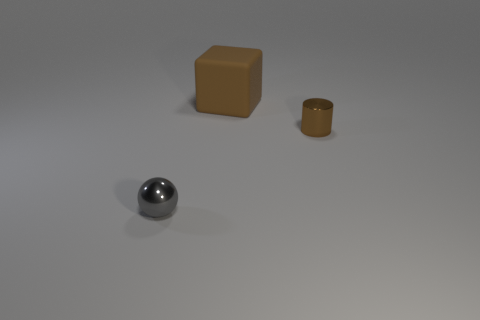There is a thing that is in front of the rubber object and behind the gray shiny thing; what color is it? brown 